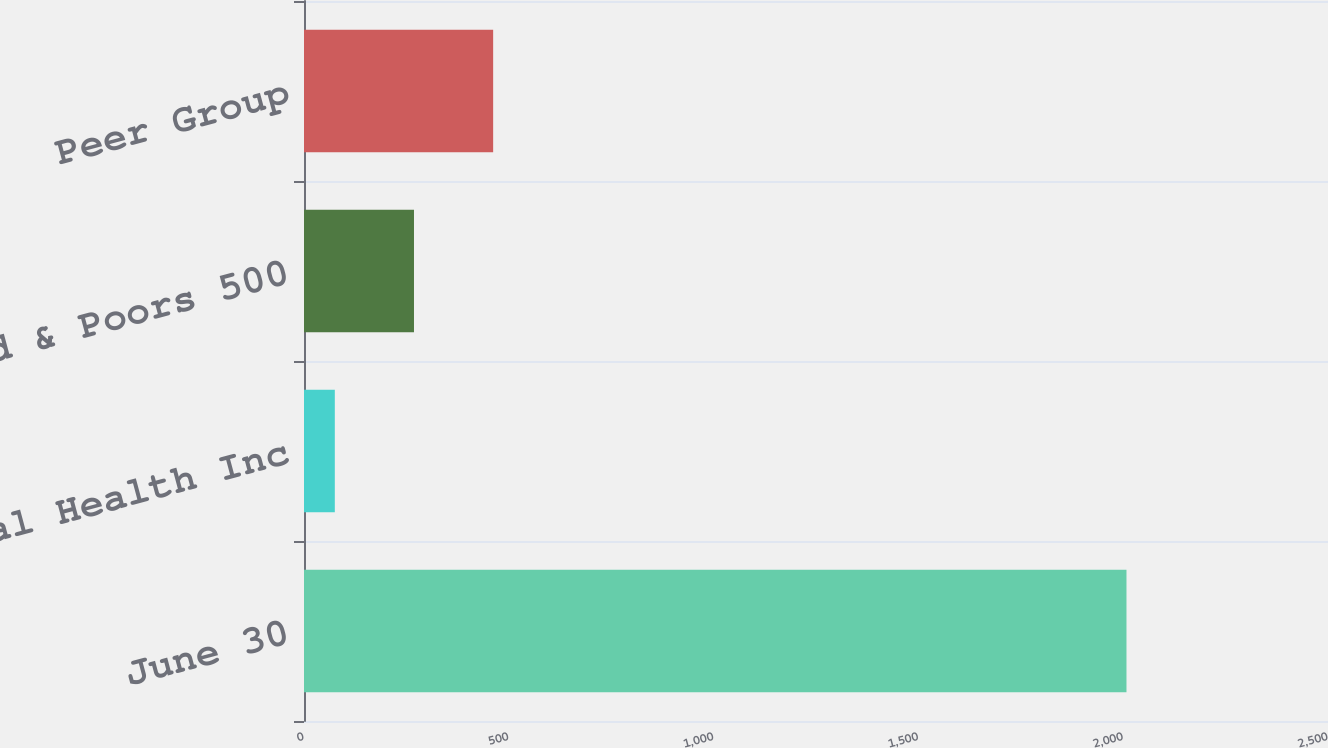<chart> <loc_0><loc_0><loc_500><loc_500><bar_chart><fcel>June 30<fcel>Cardinal Health Inc<fcel>Standard & Poors 500<fcel>Peer Group<nl><fcel>2008<fcel>75.24<fcel>268.52<fcel>461.8<nl></chart> 